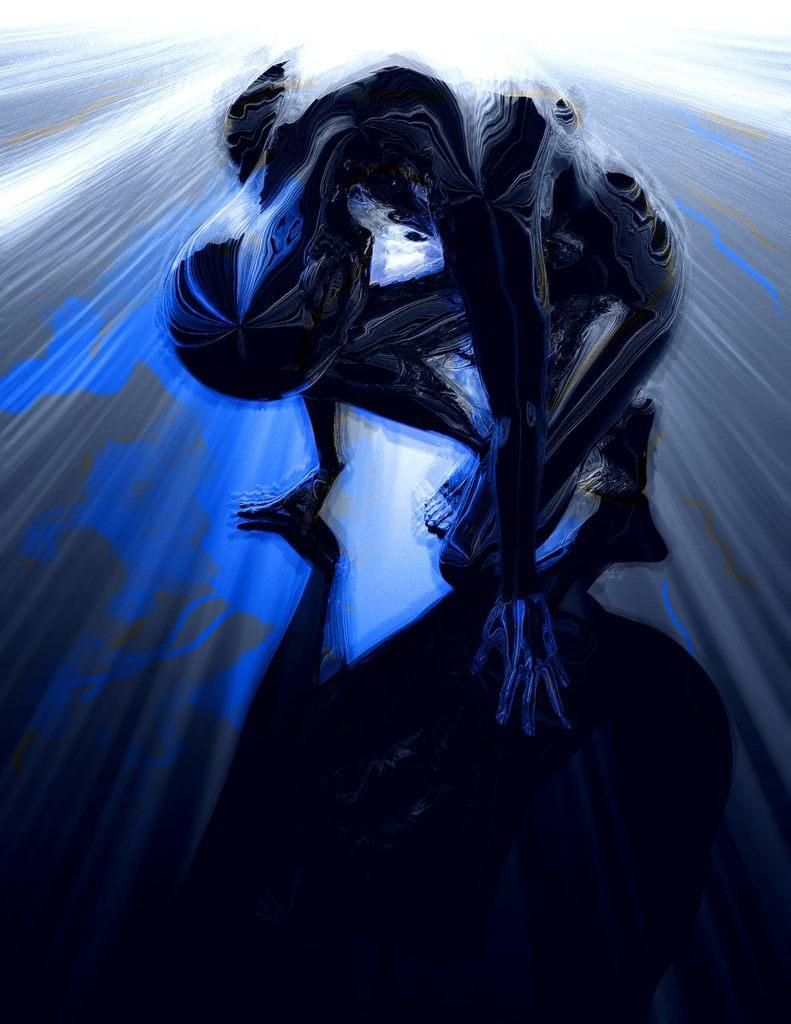What type of image is being described? The image is animated. Can you describe the subject of the image? There is a person in the image. What type of mask is the person wearing in the image? There is no mask present in the image; it is an animated image of a person. What is the person carrying in the image? The provided facts do not mention any objects being carried by the person in the image, such as a basket or toothpaste. 